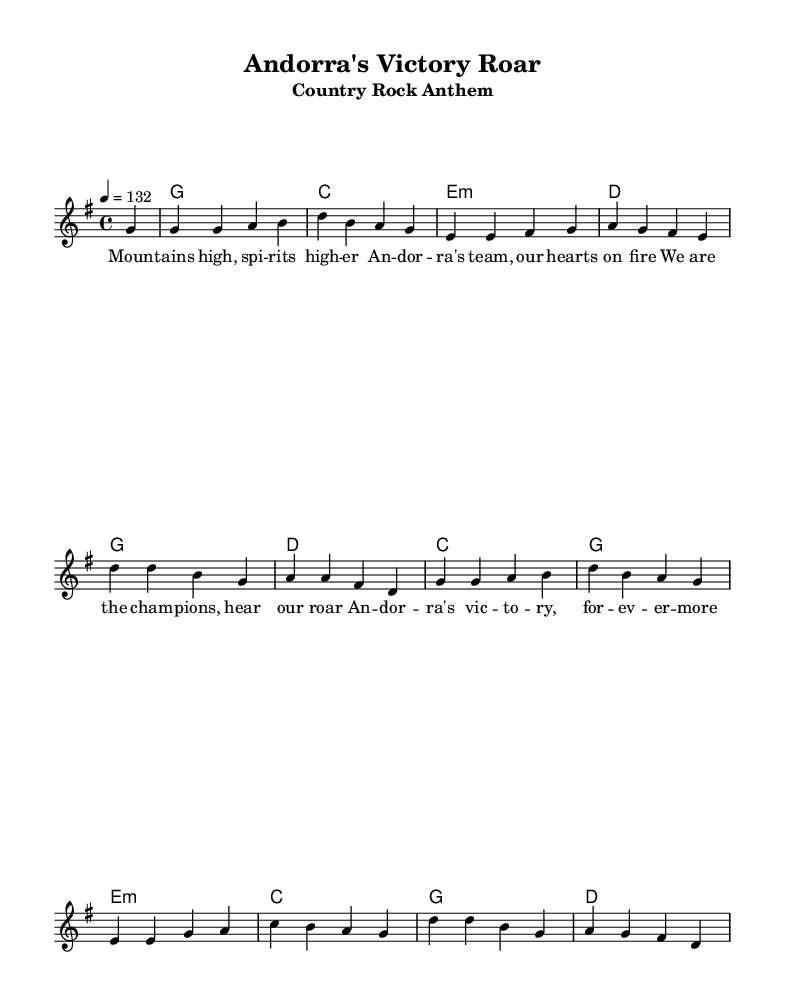What is the key signature of this music? The key signature shows one sharp, indicating that the piece is in G major.
Answer: G major What is the time signature of this music? The time signature is displayed at the beginning of the score, which shows four beats per measure, so it is 4/4.
Answer: 4/4 What is the tempo marking for this piece? The tempo marking is indicated in the score as a quarter note equals 132 beats, indicating the speed of the piece.
Answer: 132 How many measures are in the melody? By counting the segments separated by bars in the melody section, there are a total of twelve measures.
Answer: Twelve What are the first two chords of the song? The first two chords are listed under the chord names area, which are G and C, corresponding to the first two measures.
Answer: G, C What theme does the anthem emphasize based on the lyrics? The lyrics focus on celebrating victories and team spirit, highlighting the pride and success of Andorra's sports achievements.
Answer: Team spirit Which musical genre does this piece belong to? The structure, instrumentation, and themes present in the song categorize it within the country rock genre, often featuring upbeat and anthemic qualities.
Answer: Country rock 